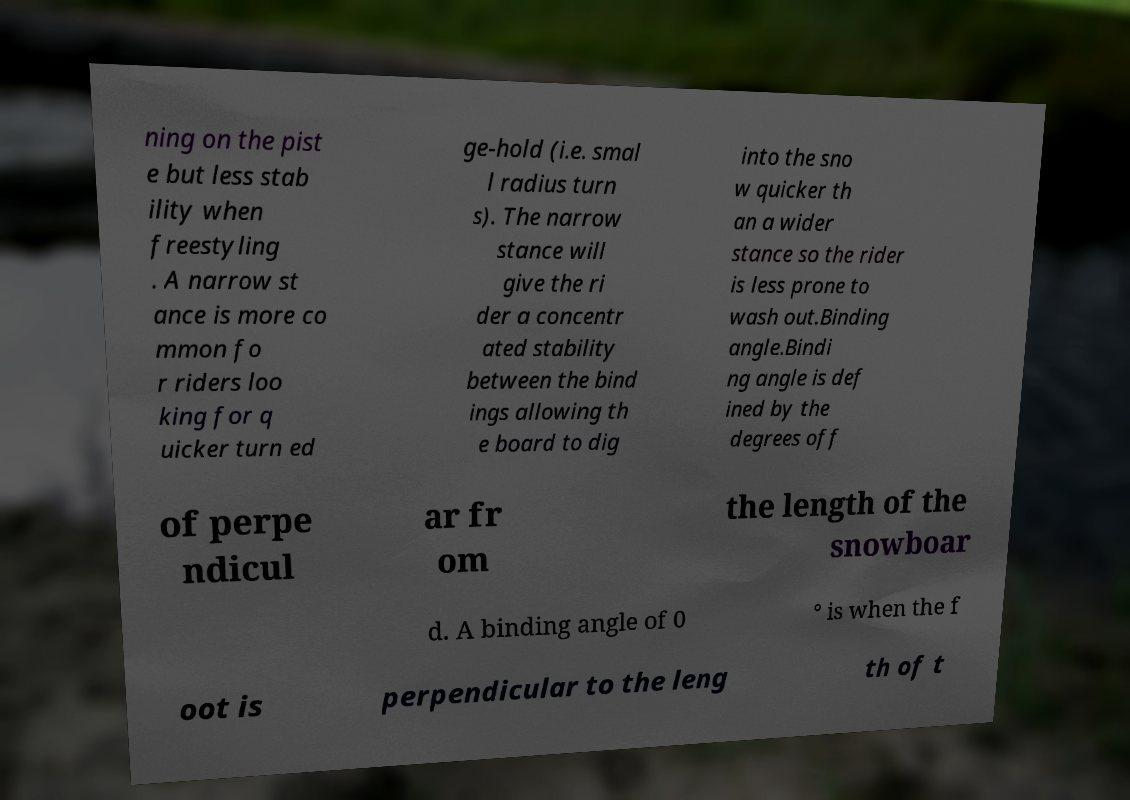Could you extract and type out the text from this image? ning on the pist e but less stab ility when freestyling . A narrow st ance is more co mmon fo r riders loo king for q uicker turn ed ge-hold (i.e. smal l radius turn s). The narrow stance will give the ri der a concentr ated stability between the bind ings allowing th e board to dig into the sno w quicker th an a wider stance so the rider is less prone to wash out.Binding angle.Bindi ng angle is def ined by the degrees off of perpe ndicul ar fr om the length of the snowboar d. A binding angle of 0 ° is when the f oot is perpendicular to the leng th of t 